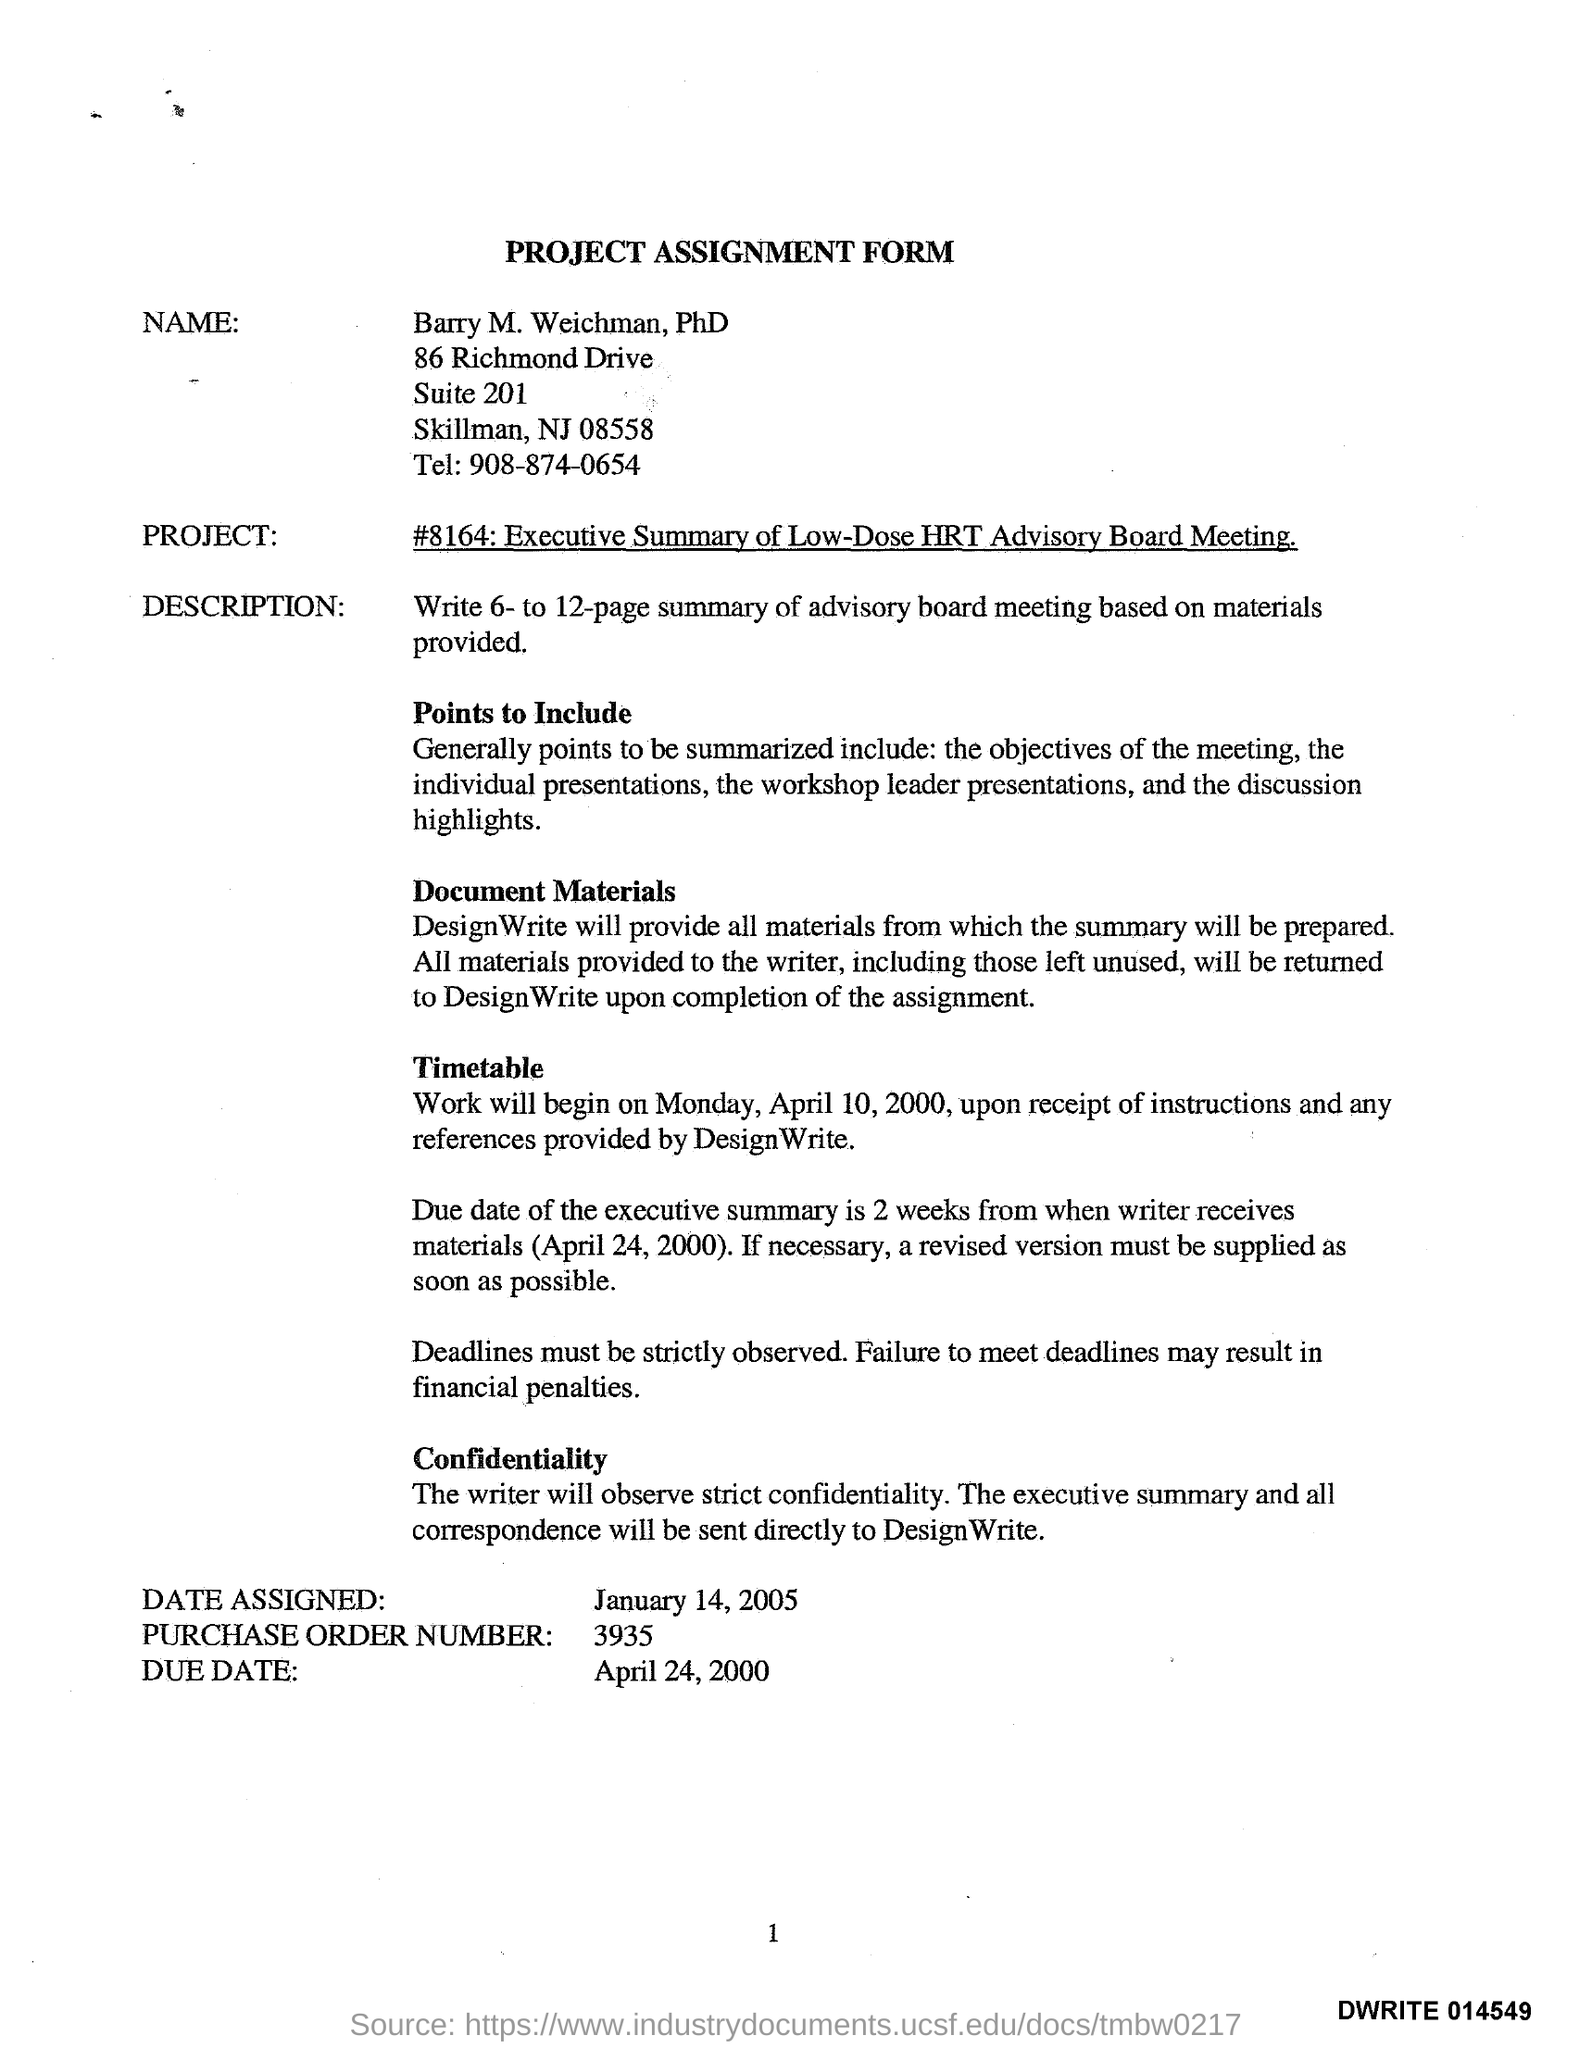Specify some key components in this picture. The work will commence on Monday, April 10, 2000. The form bears the name Barry M. Weichman, PhD. The phone number 908-874-0654 was provided as a means of communication. The title of the form is "Project Assignment Form". The date assigned is January 14, 2005. 